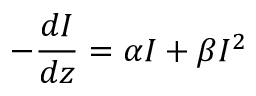<formula> <loc_0><loc_0><loc_500><loc_500>- { \frac { d I } { d z } } = \alpha I + \beta I ^ { 2 }</formula> 